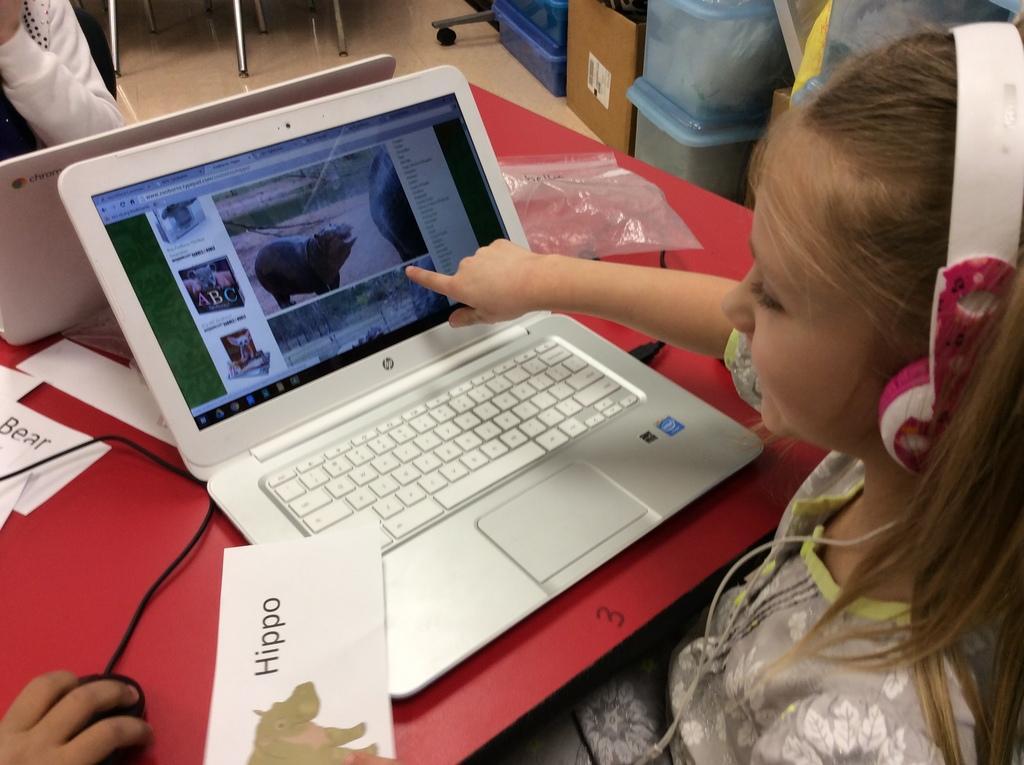Can you describe this image briefly? There is a girl sitting and wired headset, in front of this girl we can see laptops, mouse, papers, cover and cables on the table. We can see mouse hold with hand and there is a person sitting on chair. We can see boxes, cardboard box, rods and objects on the floor. 